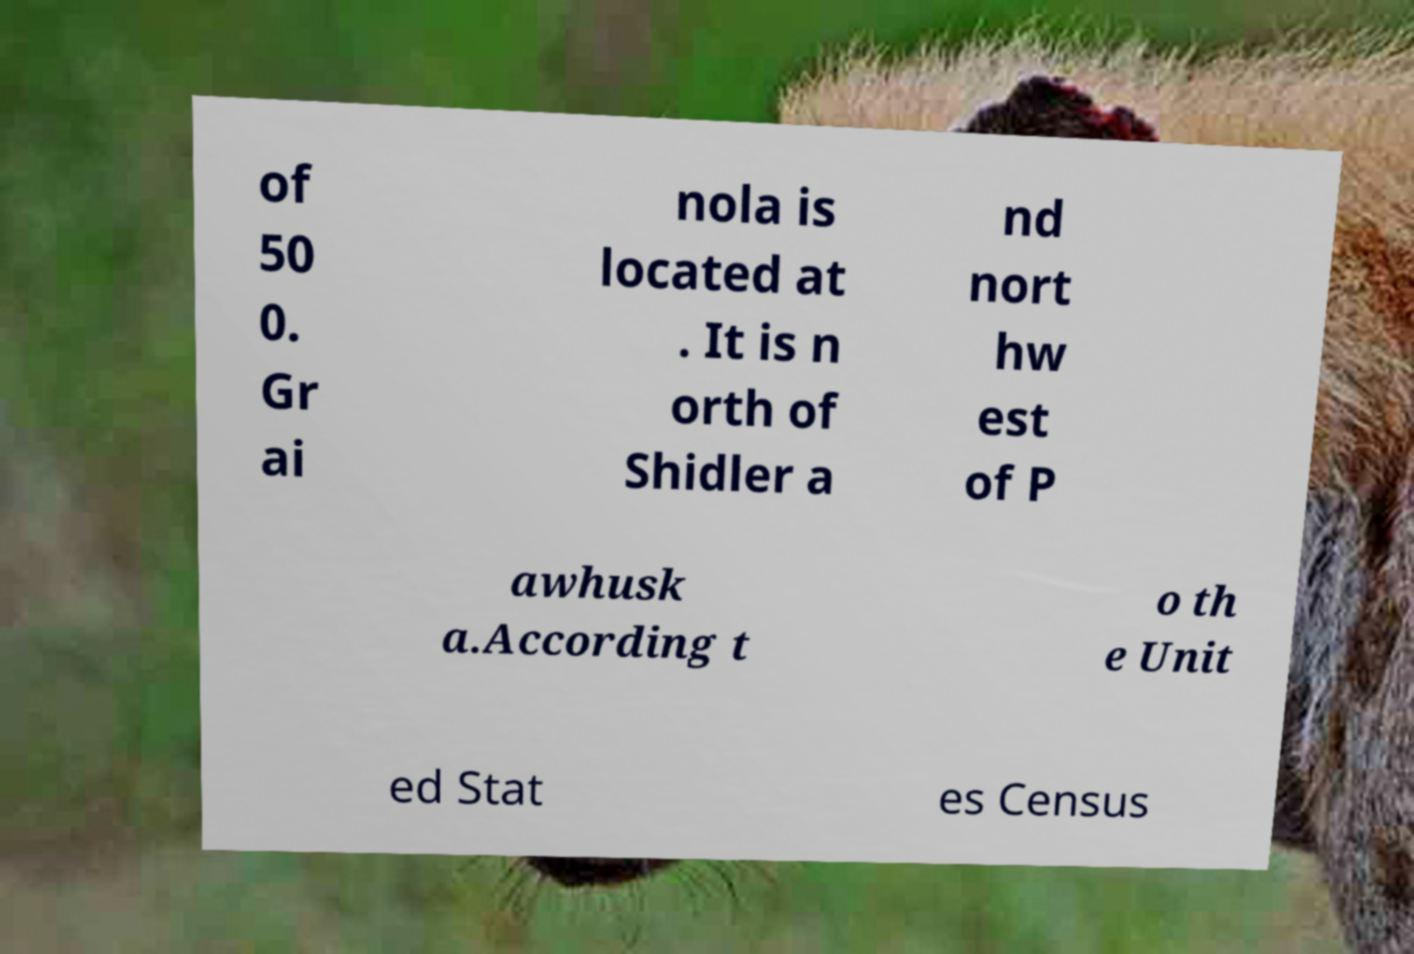Can you accurately transcribe the text from the provided image for me? of 50 0. Gr ai nola is located at . It is n orth of Shidler a nd nort hw est of P awhusk a.According t o th e Unit ed Stat es Census 